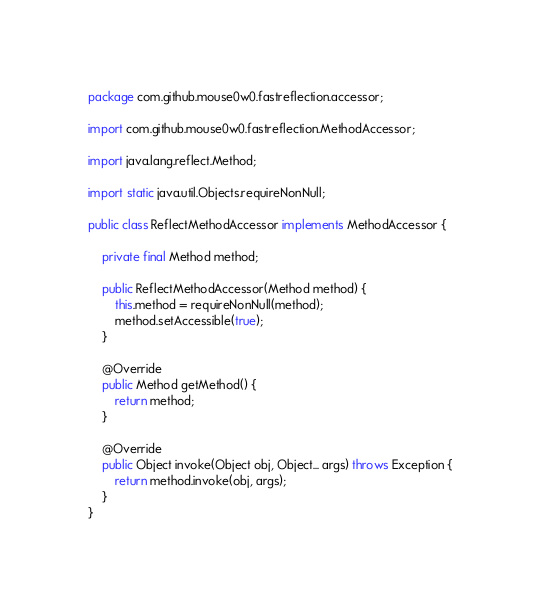<code> <loc_0><loc_0><loc_500><loc_500><_Java_>package com.github.mouse0w0.fastreflection.accessor;

import com.github.mouse0w0.fastreflection.MethodAccessor;

import java.lang.reflect.Method;

import static java.util.Objects.requireNonNull;

public class ReflectMethodAccessor implements MethodAccessor {

	private final Method method;

	public ReflectMethodAccessor(Method method) {
		this.method = requireNonNull(method);
		method.setAccessible(true);
	}

	@Override
	public Method getMethod() {
		return method;
	}

	@Override
	public Object invoke(Object obj, Object... args) throws Exception {
		return method.invoke(obj, args);
	}
}
</code> 